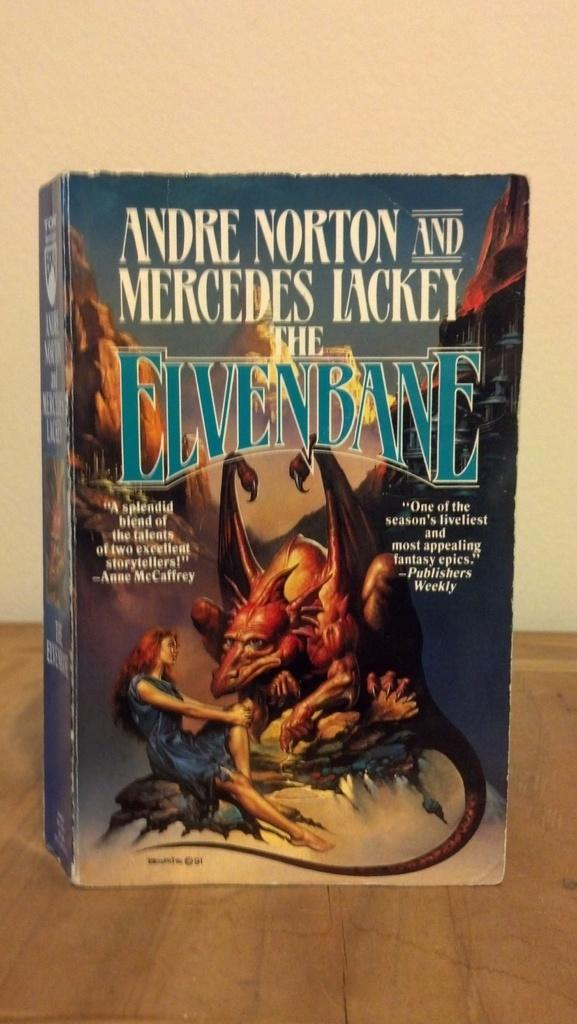What is present in the image related to reading material? There is a book in the image. What can be observed on the book's surface? The book has text and images on it. Where is the faucet located in the image? There is no faucet present in the image. What type of wealth is depicted in the images on the book? The images on the book do not depict any type of wealth; they are simply images. 